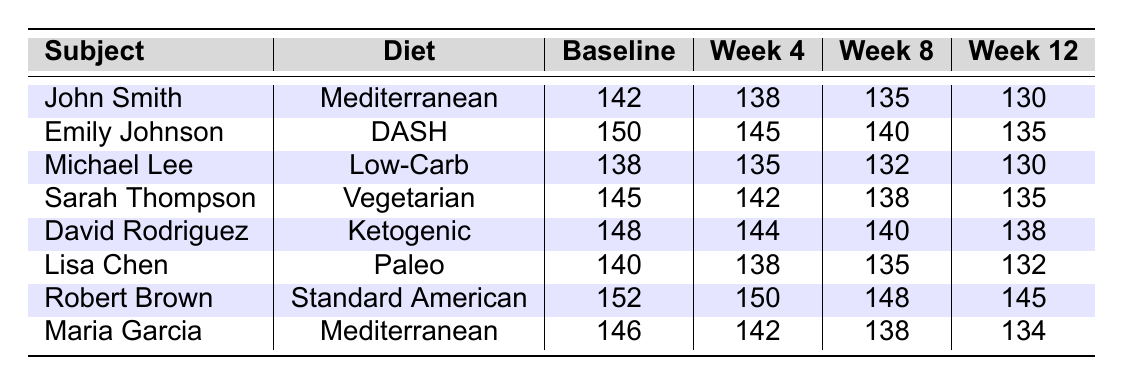What is the blood pressure of John Smith at Week 12? According to the table, John Smith's blood pressure measurement at Week 12 is recorded as 130.
Answer: 130 What was Michael Lee's Baseline blood pressure? The table shows that Michael Lee's Baseline blood pressure is 138.
Answer: 138 Which diet had the highest blood pressure at Baseline? By inspecting the Baseline column, Robert Brown's blood pressure of 152 is the highest among all subjects listed.
Answer: 152 What is the average blood pressure of subjects on the Mediterranean diet at Week 12? Combining the Week 12 values for subjects on the Mediterranean diet (John Smith 130 and Maria Garcia 134), the average is calculated as (130 + 134) / 2 = 132.
Answer: 132 Did any subject's blood pressure increase from Baseline to Week 4? Looking specifically at the Baseline and Week 4 measurements, Robert Brown's blood pressure changed from 152 to 150, and Emily Johnson's changed from 150 to 145; thus, no subject's blood pressure increased.
Answer: No Which diet showed the lowest blood pressure at Week 8? Checking the Week 8 values, Michael Lee with a Low-Carb diet has the lowest blood pressure measurement of 132.
Answer: Low-Carb What is the change in blood pressure for David Rodriguez from Baseline to Week 12? David Rodriguez's Baseline blood pressure was 148 and at Week 12, it was 138, meaning the change is 148 - 138 = 10.
Answer: 10 Which subject experienced the largest reduction in blood pressure from Baseline to Week 12? By comparing the Baseline and Week 12 measurements for each subject, John Smith, who went from 142 to 130, experienced a reduction of 12, the largest reduction.
Answer: John Smith How many subjects had blood pressure measurements below 140 at Week 12? Observing the Week 12 values, John Smith (130), Michael Lee (130), and Lisa Chen (132) are below 140, totaling 3 subjects.
Answer: 3 What is the total blood pressure of all subjects at Week 4? Summing the Week 4 blood pressure measurements: 138 + 145 + 135 + 142 + 144 + 138 + 150 + 142 = 1,134.
Answer: 1134 